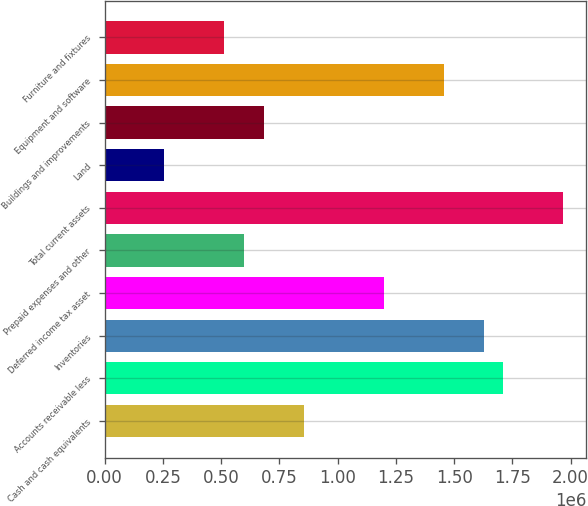Convert chart. <chart><loc_0><loc_0><loc_500><loc_500><bar_chart><fcel>Cash and cash equivalents<fcel>Accounts receivable less<fcel>Inventories<fcel>Deferred income tax asset<fcel>Prepaid expenses and other<fcel>Total current assets<fcel>Land<fcel>Buildings and improvements<fcel>Equipment and software<fcel>Furniture and fixtures<nl><fcel>856205<fcel>1.71197e+06<fcel>1.62639e+06<fcel>1.19851e+06<fcel>599476<fcel>1.9687e+06<fcel>257171<fcel>685052<fcel>1.45524e+06<fcel>513900<nl></chart> 